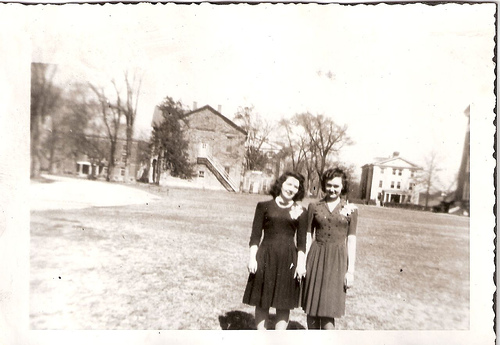<image>
Is there a woman behind the building? No. The woman is not behind the building. From this viewpoint, the woman appears to be positioned elsewhere in the scene. 